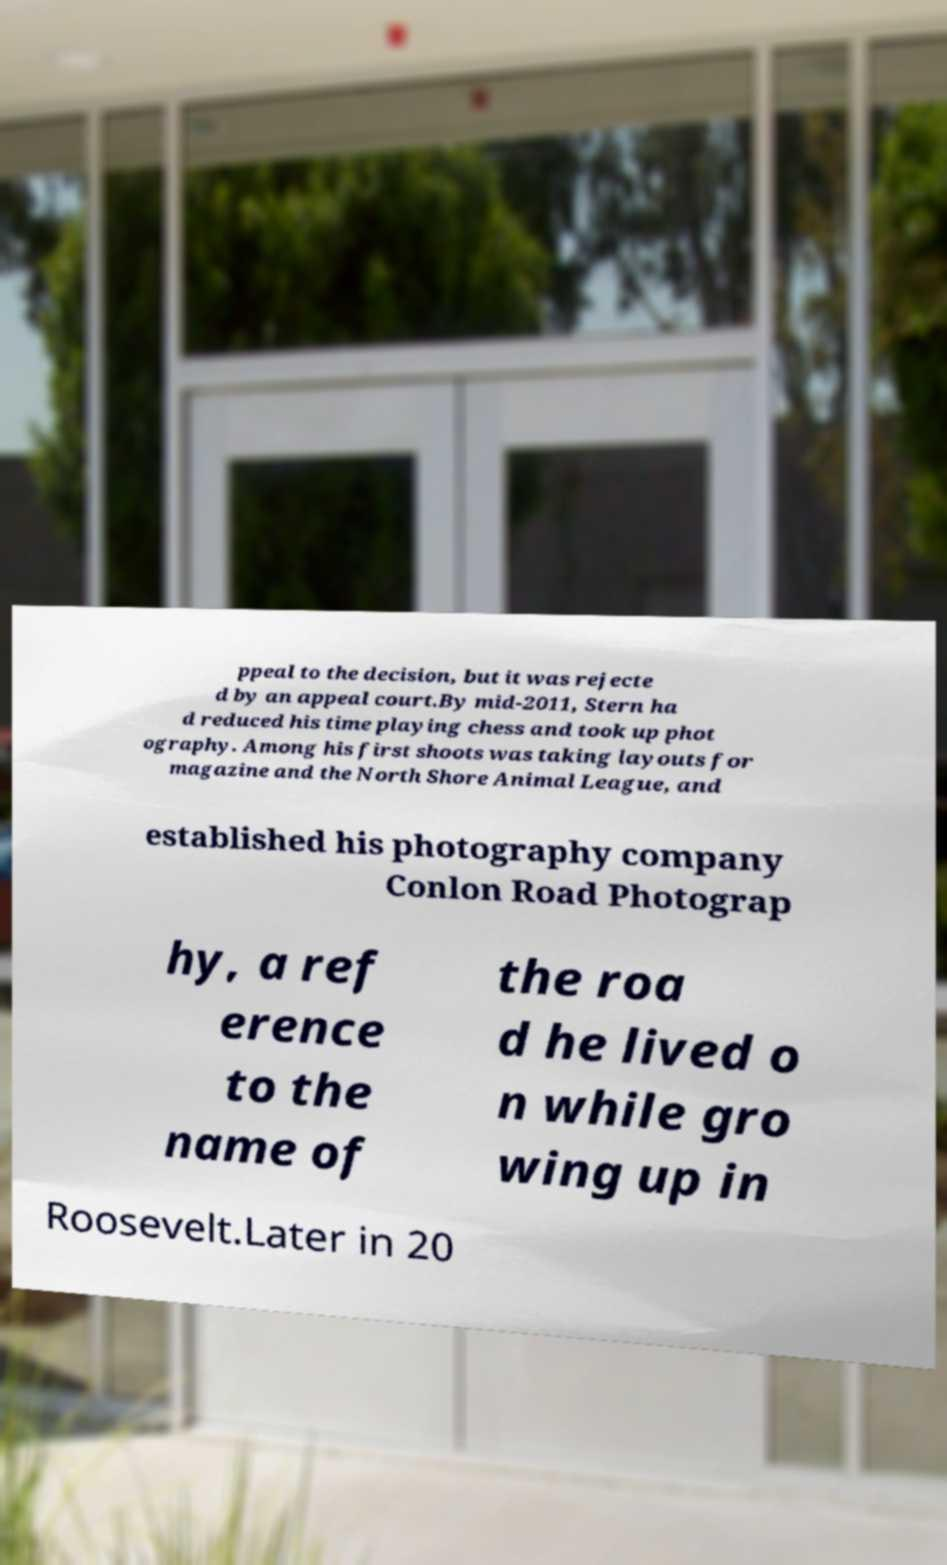Please read and relay the text visible in this image. What does it say? ppeal to the decision, but it was rejecte d by an appeal court.By mid-2011, Stern ha d reduced his time playing chess and took up phot ography. Among his first shoots was taking layouts for magazine and the North Shore Animal League, and established his photography company Conlon Road Photograp hy, a ref erence to the name of the roa d he lived o n while gro wing up in Roosevelt.Later in 20 